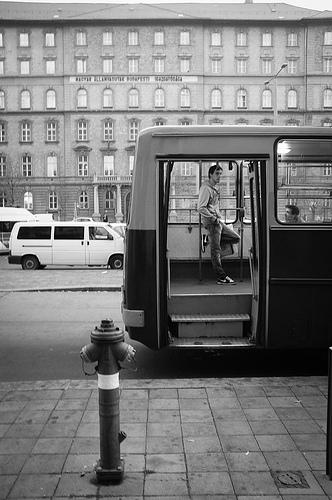What are the two largest objects found in the image? A large building with lots of windows and a passenger bus at a stop are the two largest objects found in the image. Identify the different positions of men found inside and around the bus. There is a man leaning on the bus, a man sitting inside, a man standing inside, and two men talking on the city bus. List three items you can find on the sidewalk in the image. A large fire hydrant, a square iron grate, and a drain hole can be found on the sidewalk in the image. Mention any small details observed on a fire hydrant in the image. There is a small white area present on the large fire hydrant located on the sidewalk. What is the purpose of the large sign on the apartment building? The large sign on the apartment building displays the name of the building and serves as an identification marker. Describe the appearance of the building in the image. The large building in the image has many windows, arched windows, a banner with the name of the building, and pillars on its front. Explain the interaction between people on the bus. On the city bus, there are two people talking while one man is sitting and another man is standing. Describe the parking situation observed in the image. A white van is parked on one side of the bus while a white mini van is parked on the other side of the bus, across the city street. What types of vehicles are visible in the image? A white mini van, a rear of a passenger bus, and a white van on the road are visible in the image. Provide a brief description of what's happening on the city street. On a paved city street, a white van is parked, a city bus is waiting at a bus stop, and a man is leaning against a post while people interact on the bus. Describe the rear of the passenger bus. Bus door open, steps going up to the bus, passengers standing and sitting inside What type of object is at the coordinates X:135 Y:465? Small black spot on ground Create a short story based on the man leaning against the post and the city bus. The man, wearing jeans and a sweatshirt, leaned against a post while waiting for the city bus to arrive. The bus was delayed, which made his impatience grow. Inside the bus, people were engaging in conversations while others stood or sat. When the bus finally arrived, he would then board and continue his journey. Look carefully for the graffiti on the side of the white van. The image contains no information about any graffiti on the van, which means this instruction will mislead the viewer into looking for nonexistent details. Describe the environment around the parked white van. City street, near a large building with arched windows, and a passenger bus at a stop on the other side of the street What object in the image is related to transportation? Passenger bus at a stop Notice how the man leaning against the post is wearing sunglasses and a hat. There is no information about the man's attire in the original image captions; this instruction is misleading because it adds false information. Can you spot the airplane flying in the sky above the bus? There's no mention of an airplane in the image, making the question misleading as the viewer may search for an object that isn't there. What is a notable feature of the fire hydrant in the image? Small white area Describe the position and appearance of the fire hydrant in the image. Large fire hydrant on sidewalk at X:34 Y:312, with small white area on it List the activities happening inside the city bus. Man standing, man sitting, and two people talking What event is occurring at the bus stop? City bus waiting at bus stop Find the red umbrella in the large window of the building. There is no information about a red umbrella in the window in the image, leading the viewer to search for an object that doesn't exist, making the instruction misleading. Create a short story involving the fire hydrant on the city street. On a busy city street, a fire hydrant stood tall next to the sidewalk. One day, a car took a sharp turn and hit the hydrant, causing water to spray everywhere. This created chaos and excitement for the pedestrians passing by. Examine the red flowers growing near the steps going up to the bus. The image contains no information about any flowers, so this instruction sends the viewer on a wild goose chase. Observe closely, and you will find a cat sitting on the roof of the large building. The instruction claims that there is a cat sitting on the roof of the large building, but there is no information about a cat in the image, which makes the statement misleading. What type of object is found on the ground at coordinates X:257 Y:465? Square iron grate Identify the expression of the man sitting on the bus. Facial expression cannot be determined from provided data Which item at X:184 Y:163 and X:196 Y:163 is larger? Man leaning against post Are you able to find a small yellow ball on the ground near the fire hydrant? There is no information about a yellow ball in the image, and the instruction asks the viewer to find something that doesn't exist, which is misleading. Analyze the diagram and describe the large building. Large building with lots of windows and arched windows, roof, and pillars on the side Among the objects in the image, which one can be categorized as iron infrastructure? Square iron grate on ground What event is taking place involving the white van? White van parked on city street The trees along the sidewalk beside the bus provide a nice, shady spot, don't you think? There is no mention of trees in the image, which makes the statement misleading because it refers to something nonexistent. Analyze the image and describe the placement of the building's name. Name of the building written on the building at X:65 Y:74 The blue bicycle is parked next to the white van, isn't it? There's no mention of a bicycle in the image, so the viewer might look for an object that doesn't exist, making the instruction misleading. Tell me if you see the children playing by the building with lots of windows. There is no mention of any children playing in the image, which makes the question misleading, as it may cause confusion searching for something that is not present. List three objects visible on the sidewalk. Fire hydrant, drain hole, cement tiles 